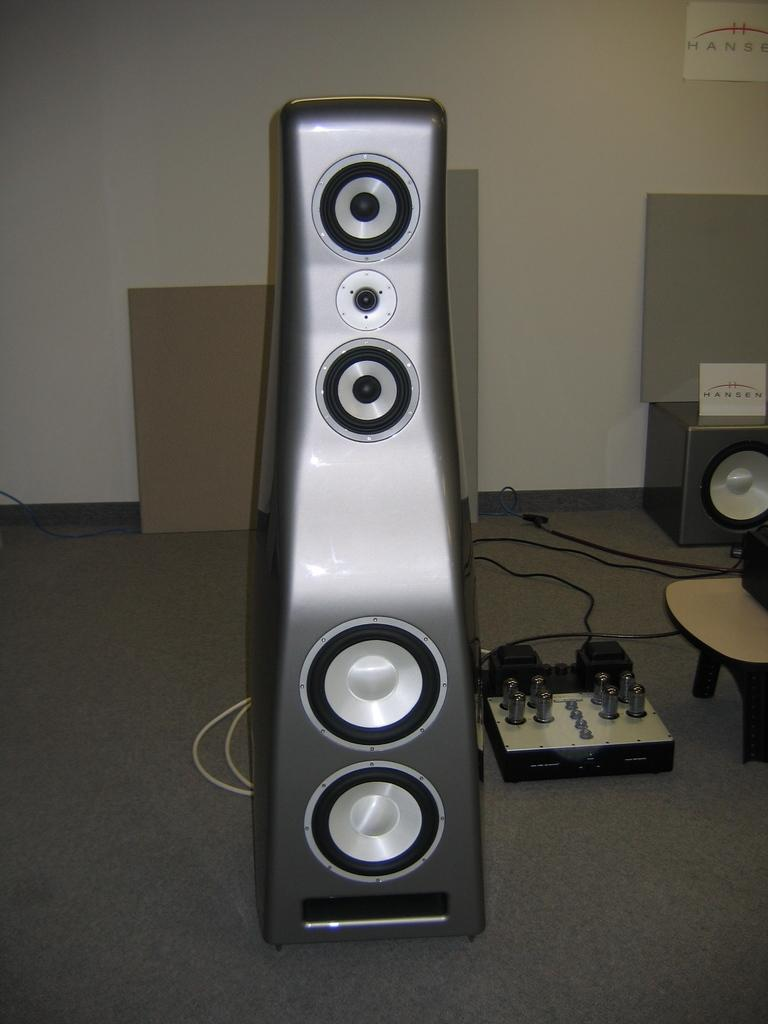What is the surface on which the speakers are placed in the image? The speakers are placed on the floor in the image. What else can be found on the floor besides the speakers? There are objects on the floor in the image. What type of furniture is present in the image? There is a table in the image. What are the devices used for in the image? The devices are used for various purposes, such as playing music or displaying information. How are the devices connected to each other or the speakers? Cables are present in the image, which may be used to connect the devices and speakers. What can be seen on the wall in the background of the image? There is a poster on the wall in the background of the image. Can you tell me how many kitties are sitting on the judge's lap in the image? There are no kitties or judges present in the image. What type of base is supporting the table in the image? The image does not provide information about the base of the table. 